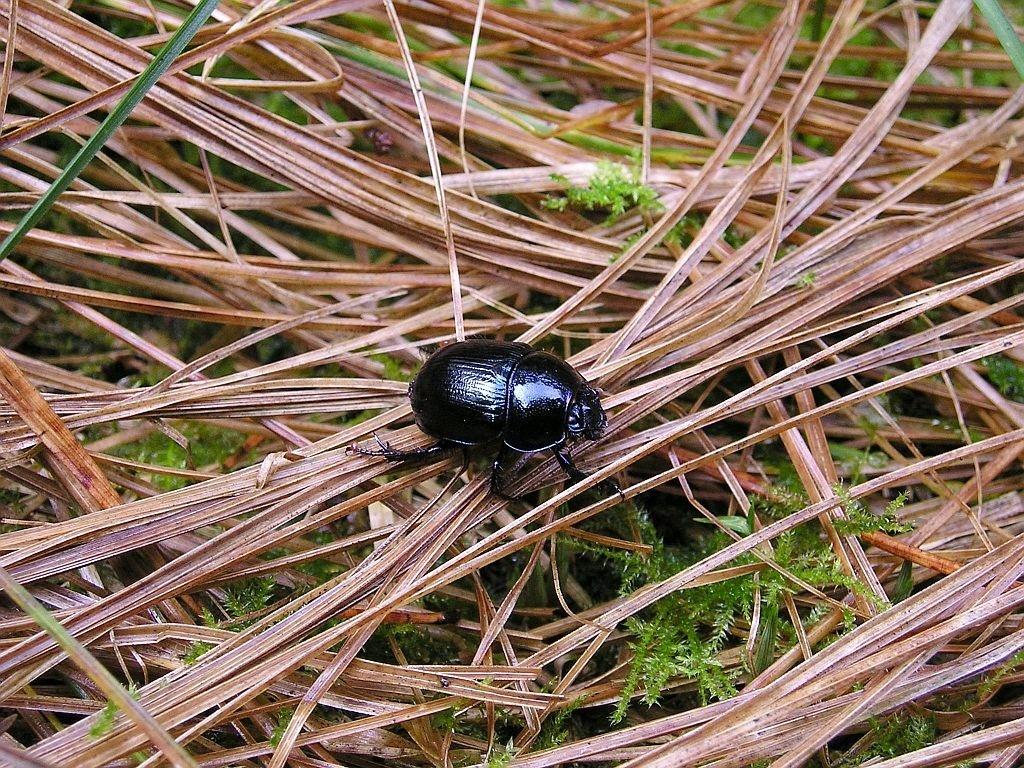What type of creature can be seen in the picture? There is an insect in the picture. What is the color of the insect? The insect is black in color. What other elements are present in the picture besides the insect? There are leaves in the picture. What colors can be observed in the leaves? The leaves are brown and green in color. What type of soup is being served in the picture? There is no soup present in the picture; it features an insect and leaves. Can you tell me the flavor of the berry in the picture? There is no berry present in the picture; it only contains an insect and leaves. 